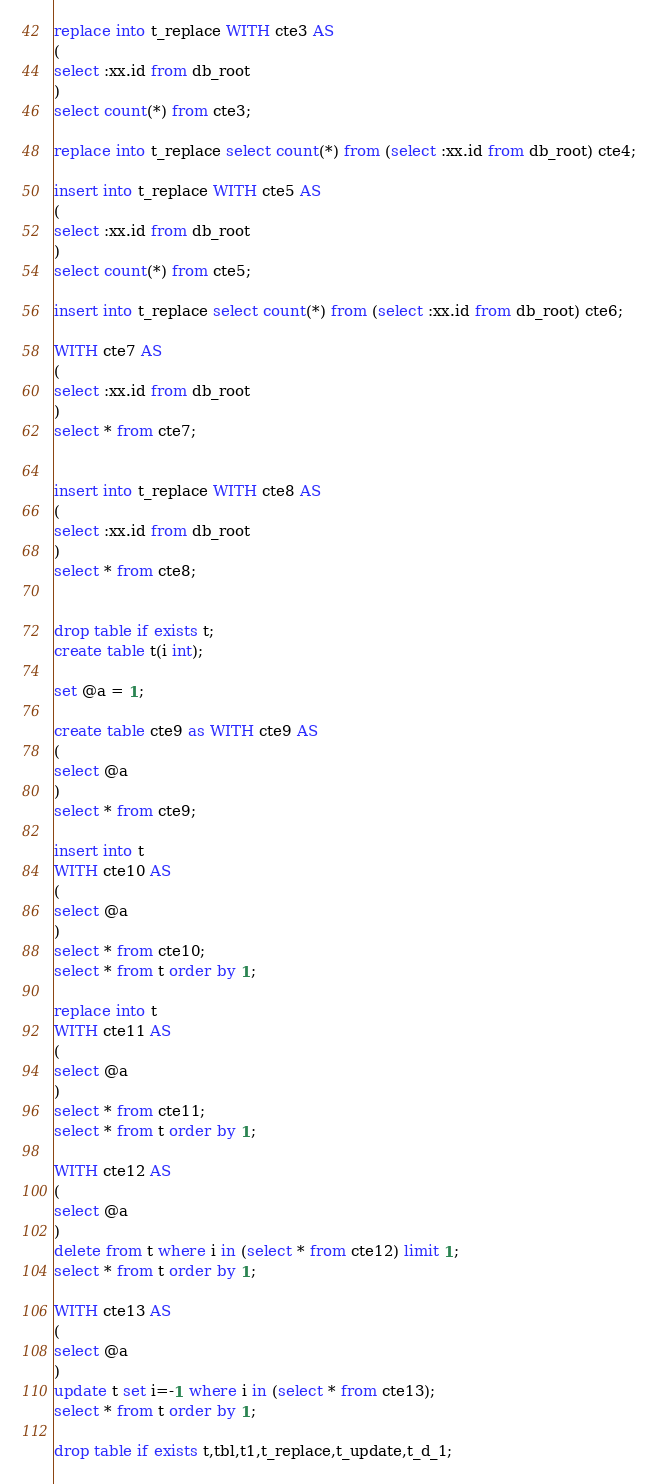<code> <loc_0><loc_0><loc_500><loc_500><_SQL_>
replace into t_replace WITH cte3 AS
(
select :xx.id from db_root
)
select count(*) from cte3;

replace into t_replace select count(*) from (select :xx.id from db_root) cte4;

insert into t_replace WITH cte5 AS
(
select :xx.id from db_root
)
select count(*) from cte5;

insert into t_replace select count(*) from (select :xx.id from db_root) cte6;

WITH cte7 AS
(
select :xx.id from db_root
)
select * from cte7;


insert into t_replace WITH cte8 AS
(
select :xx.id from db_root
)
select * from cte8;


drop table if exists t;
create table t(i int);

set @a = 1;

create table cte9 as WITH cte9 AS
(
select @a
)
select * from cte9;

insert into t 
WITH cte10 AS
(
select @a
)
select * from cte10;
select * from t order by 1;

replace into t 
WITH cte11 AS
(
select @a
)
select * from cte11;
select * from t order by 1;

WITH cte12 AS
(
select @a
)
delete from t where i in (select * from cte12) limit 1;
select * from t order by 1;

WITH cte13 AS
(
select @a
)
update t set i=-1 where i in (select * from cte13);
select * from t order by 1;

drop table if exists t,tbl,t1,t_replace,t_update,t_d_1;
</code> 